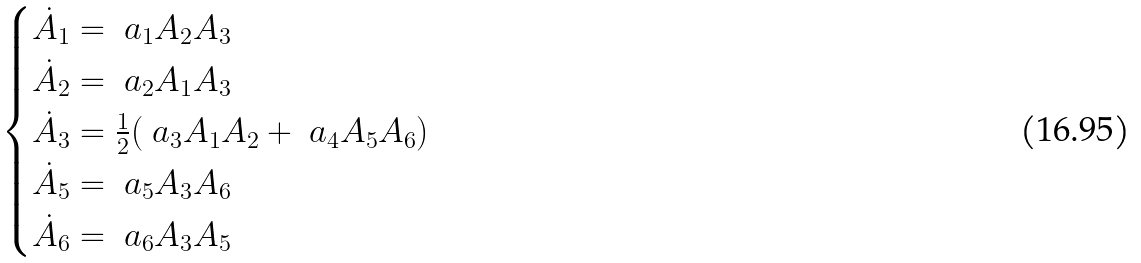Convert formula to latex. <formula><loc_0><loc_0><loc_500><loc_500>\begin{cases} \dot { A } _ { 1 } = \ a _ { 1 } A _ { 2 } A _ { 3 } \\ \dot { A } _ { 2 } = \ a _ { 2 } A _ { 1 } A _ { 3 } \\ \dot { A } _ { 3 } = \frac { 1 } { 2 } ( \ a _ { 3 } A _ { 1 } A _ { 2 } + \ a _ { 4 } A _ { 5 } A _ { 6 } ) \\ \dot { A } _ { 5 } = \ a _ { 5 } A _ { 3 } A _ { 6 } \\ \dot { A } _ { 6 } = \ a _ { 6 } A _ { 3 } A _ { 5 } \end{cases}</formula> 